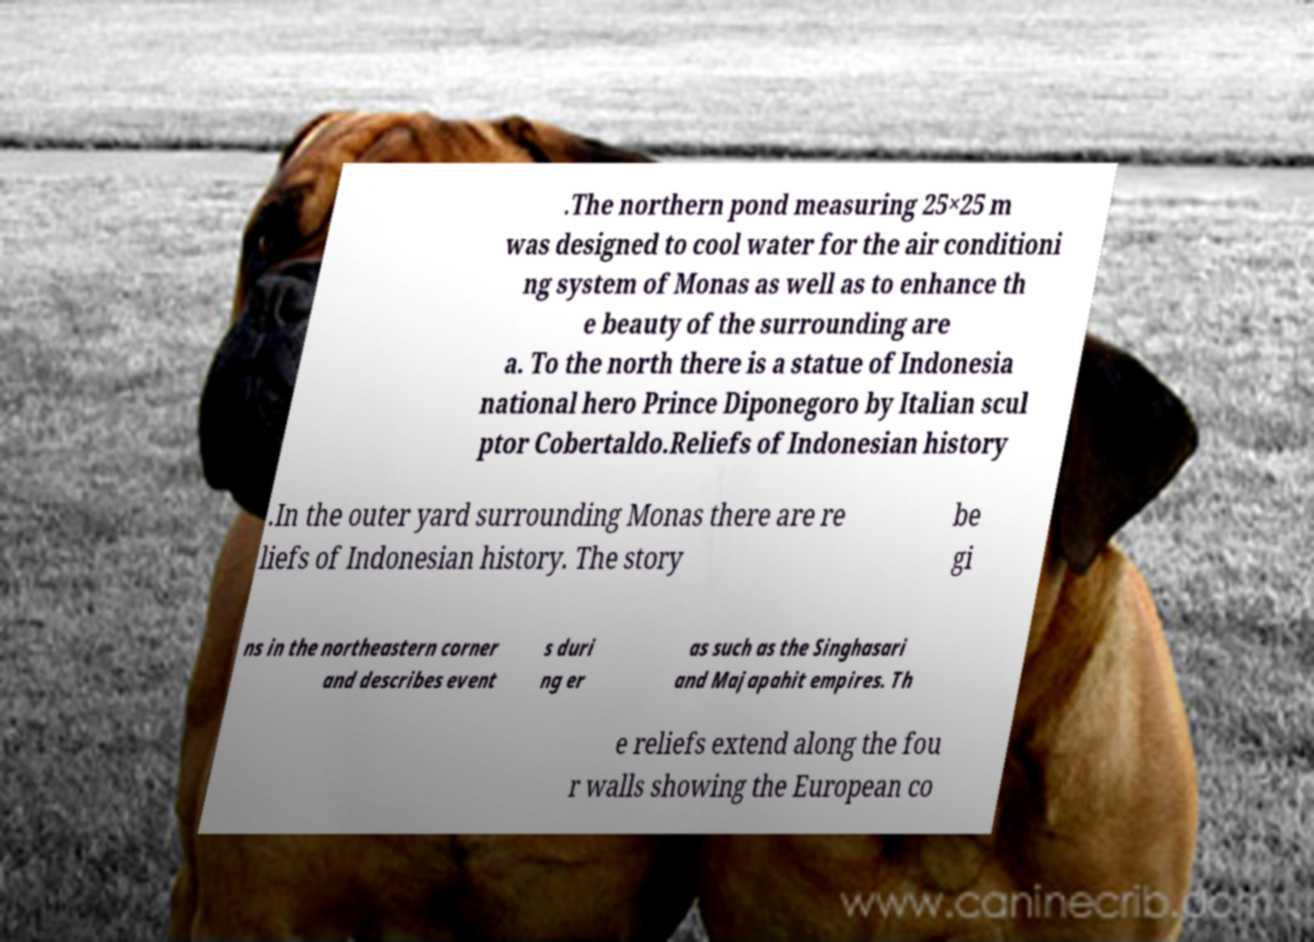Please identify and transcribe the text found in this image. .The northern pond measuring 25×25 m was designed to cool water for the air conditioni ng system of Monas as well as to enhance th e beauty of the surrounding are a. To the north there is a statue of Indonesia national hero Prince Diponegoro by Italian scul ptor Cobertaldo.Reliefs of Indonesian history .In the outer yard surrounding Monas there are re liefs of Indonesian history. The story be gi ns in the northeastern corner and describes event s duri ng er as such as the Singhasari and Majapahit empires. Th e reliefs extend along the fou r walls showing the European co 